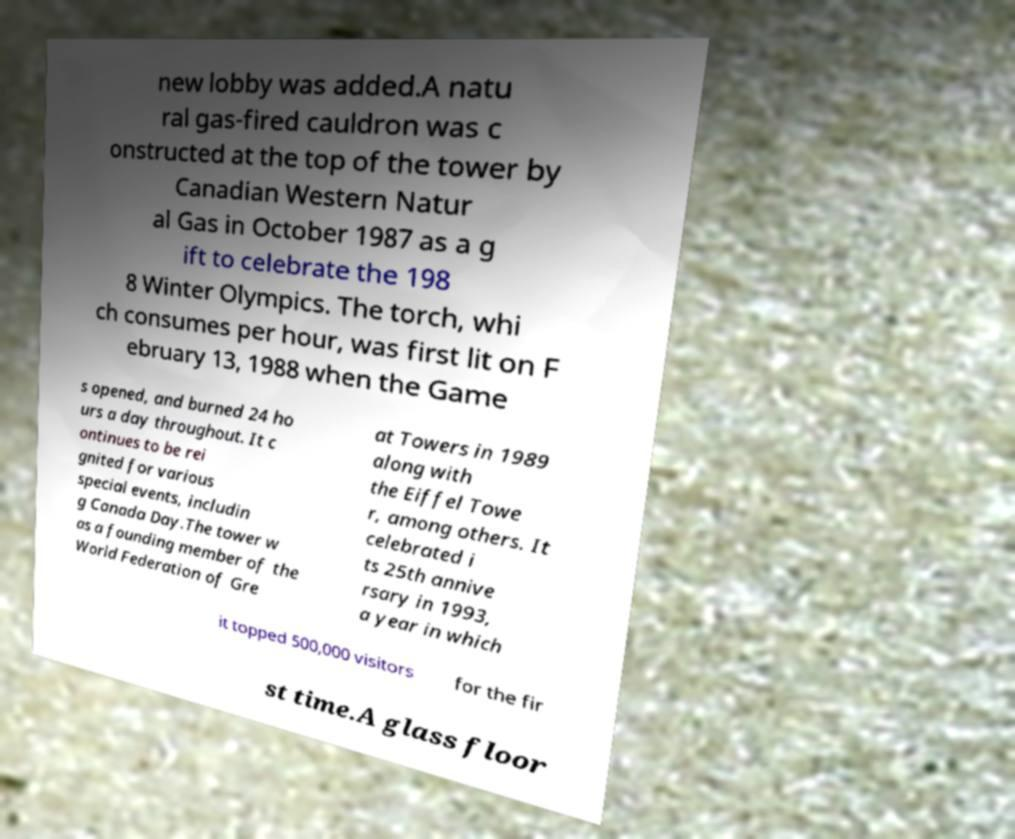I need the written content from this picture converted into text. Can you do that? new lobby was added.A natu ral gas-fired cauldron was c onstructed at the top of the tower by Canadian Western Natur al Gas in October 1987 as a g ift to celebrate the 198 8 Winter Olympics. The torch, whi ch consumes per hour, was first lit on F ebruary 13, 1988 when the Game s opened, and burned 24 ho urs a day throughout. It c ontinues to be rei gnited for various special events, includin g Canada Day.The tower w as a founding member of the World Federation of Gre at Towers in 1989 along with the Eiffel Towe r, among others. It celebrated i ts 25th annive rsary in 1993, a year in which it topped 500,000 visitors for the fir st time.A glass floor 